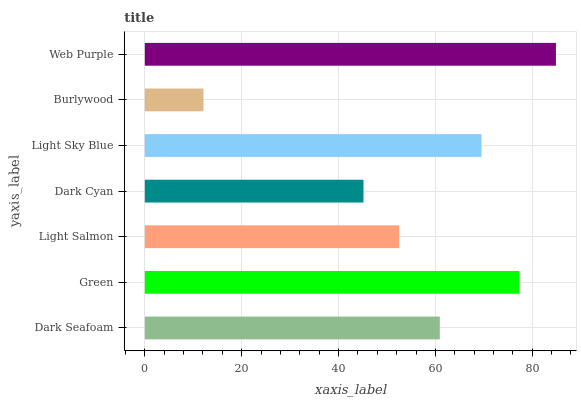Is Burlywood the minimum?
Answer yes or no. Yes. Is Web Purple the maximum?
Answer yes or no. Yes. Is Green the minimum?
Answer yes or no. No. Is Green the maximum?
Answer yes or no. No. Is Green greater than Dark Seafoam?
Answer yes or no. Yes. Is Dark Seafoam less than Green?
Answer yes or no. Yes. Is Dark Seafoam greater than Green?
Answer yes or no. No. Is Green less than Dark Seafoam?
Answer yes or no. No. Is Dark Seafoam the high median?
Answer yes or no. Yes. Is Dark Seafoam the low median?
Answer yes or no. Yes. Is Web Purple the high median?
Answer yes or no. No. Is Web Purple the low median?
Answer yes or no. No. 